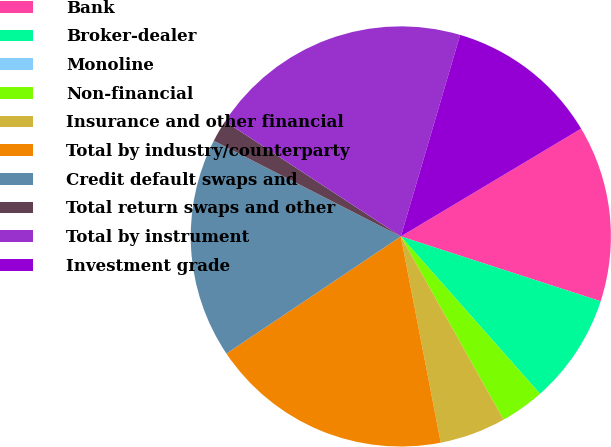Convert chart. <chart><loc_0><loc_0><loc_500><loc_500><pie_chart><fcel>Bank<fcel>Broker-dealer<fcel>Monoline<fcel>Non-financial<fcel>Insurance and other financial<fcel>Total by industry/counterparty<fcel>Credit default swaps and<fcel>Total return swaps and other<fcel>Total by instrument<fcel>Investment grade<nl><fcel>13.57%<fcel>8.48%<fcel>0.0%<fcel>3.39%<fcel>5.09%<fcel>18.63%<fcel>16.94%<fcel>1.7%<fcel>20.33%<fcel>11.87%<nl></chart> 